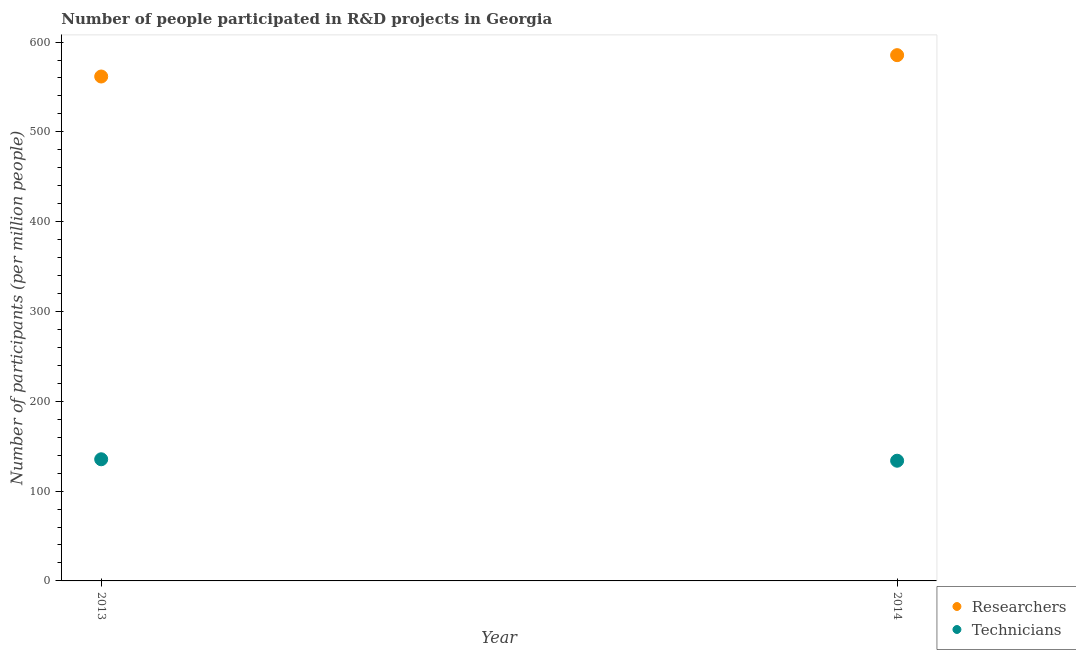How many different coloured dotlines are there?
Offer a very short reply. 2. Is the number of dotlines equal to the number of legend labels?
Your answer should be compact. Yes. What is the number of researchers in 2014?
Keep it short and to the point. 585.41. Across all years, what is the maximum number of researchers?
Offer a very short reply. 585.41. Across all years, what is the minimum number of researchers?
Keep it short and to the point. 561.63. What is the total number of researchers in the graph?
Provide a succinct answer. 1147.05. What is the difference between the number of technicians in 2013 and that in 2014?
Your response must be concise. 1.61. What is the difference between the number of researchers in 2014 and the number of technicians in 2013?
Give a very brief answer. 449.96. What is the average number of researchers per year?
Your response must be concise. 573.52. In the year 2013, what is the difference between the number of technicians and number of researchers?
Your response must be concise. -426.19. In how many years, is the number of technicians greater than 560?
Keep it short and to the point. 0. What is the ratio of the number of technicians in 2013 to that in 2014?
Give a very brief answer. 1.01. Is the number of technicians in 2013 less than that in 2014?
Keep it short and to the point. No. Does the number of researchers monotonically increase over the years?
Keep it short and to the point. Yes. Are the values on the major ticks of Y-axis written in scientific E-notation?
Ensure brevity in your answer.  No. Does the graph contain any zero values?
Ensure brevity in your answer.  No. Does the graph contain grids?
Offer a very short reply. No. Where does the legend appear in the graph?
Your answer should be compact. Bottom right. What is the title of the graph?
Make the answer very short. Number of people participated in R&D projects in Georgia. Does "Private credit bureau" appear as one of the legend labels in the graph?
Offer a terse response. No. What is the label or title of the Y-axis?
Provide a succinct answer. Number of participants (per million people). What is the Number of participants (per million people) in Researchers in 2013?
Keep it short and to the point. 561.63. What is the Number of participants (per million people) in Technicians in 2013?
Offer a very short reply. 135.45. What is the Number of participants (per million people) in Researchers in 2014?
Provide a short and direct response. 585.41. What is the Number of participants (per million people) of Technicians in 2014?
Ensure brevity in your answer.  133.84. Across all years, what is the maximum Number of participants (per million people) of Researchers?
Give a very brief answer. 585.41. Across all years, what is the maximum Number of participants (per million people) of Technicians?
Provide a succinct answer. 135.45. Across all years, what is the minimum Number of participants (per million people) of Researchers?
Provide a succinct answer. 561.63. Across all years, what is the minimum Number of participants (per million people) in Technicians?
Keep it short and to the point. 133.84. What is the total Number of participants (per million people) in Researchers in the graph?
Make the answer very short. 1147.05. What is the total Number of participants (per million people) of Technicians in the graph?
Provide a succinct answer. 269.29. What is the difference between the Number of participants (per million people) in Researchers in 2013 and that in 2014?
Ensure brevity in your answer.  -23.78. What is the difference between the Number of participants (per million people) in Technicians in 2013 and that in 2014?
Offer a terse response. 1.61. What is the difference between the Number of participants (per million people) of Researchers in 2013 and the Number of participants (per million people) of Technicians in 2014?
Give a very brief answer. 427.8. What is the average Number of participants (per million people) in Researchers per year?
Ensure brevity in your answer.  573.52. What is the average Number of participants (per million people) of Technicians per year?
Offer a very short reply. 134.64. In the year 2013, what is the difference between the Number of participants (per million people) of Researchers and Number of participants (per million people) of Technicians?
Provide a short and direct response. 426.19. In the year 2014, what is the difference between the Number of participants (per million people) in Researchers and Number of participants (per million people) in Technicians?
Provide a succinct answer. 451.57. What is the ratio of the Number of participants (per million people) of Researchers in 2013 to that in 2014?
Provide a succinct answer. 0.96. What is the difference between the highest and the second highest Number of participants (per million people) of Researchers?
Offer a terse response. 23.78. What is the difference between the highest and the second highest Number of participants (per million people) in Technicians?
Provide a succinct answer. 1.61. What is the difference between the highest and the lowest Number of participants (per million people) of Researchers?
Offer a terse response. 23.78. What is the difference between the highest and the lowest Number of participants (per million people) in Technicians?
Offer a terse response. 1.61. 